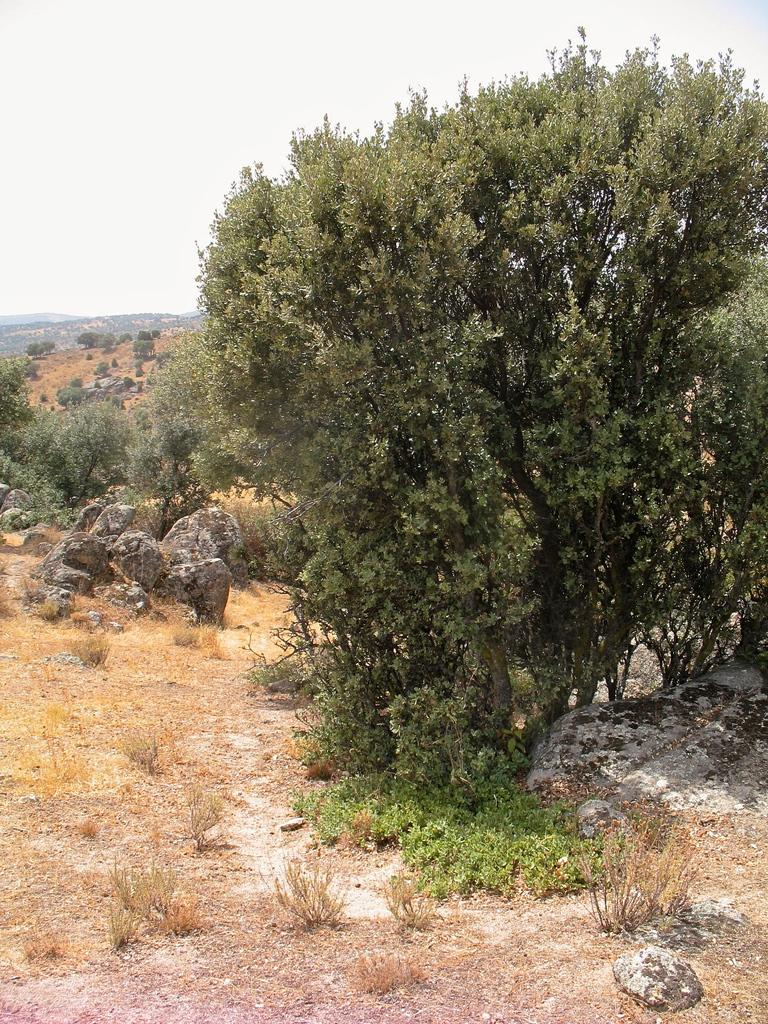What type of vegetation can be seen in the image? There are trees in the image. What other natural elements are present in the image? There are stones and grass in the image. What type of landscape feature can be seen in the distance? There are mountains in the image. What is visible in the background of the image? The sky is visible in the background of the image. What type of furniture is present in the image? There is no furniture present in the image; it features natural elements such as trees, stones, grass, mountains, and the sky. How does the growth of the trees in the image compare to the growth of trees in a different climate? The image does not provide enough information to compare the growth of the trees to those in a different climate. 